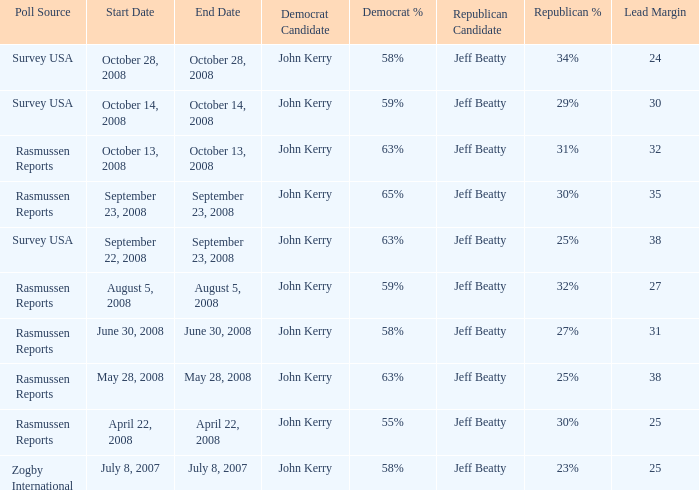Who is the poll source that has Republican: Jeff Beatty behind at 27%? Rasmussen Reports. 